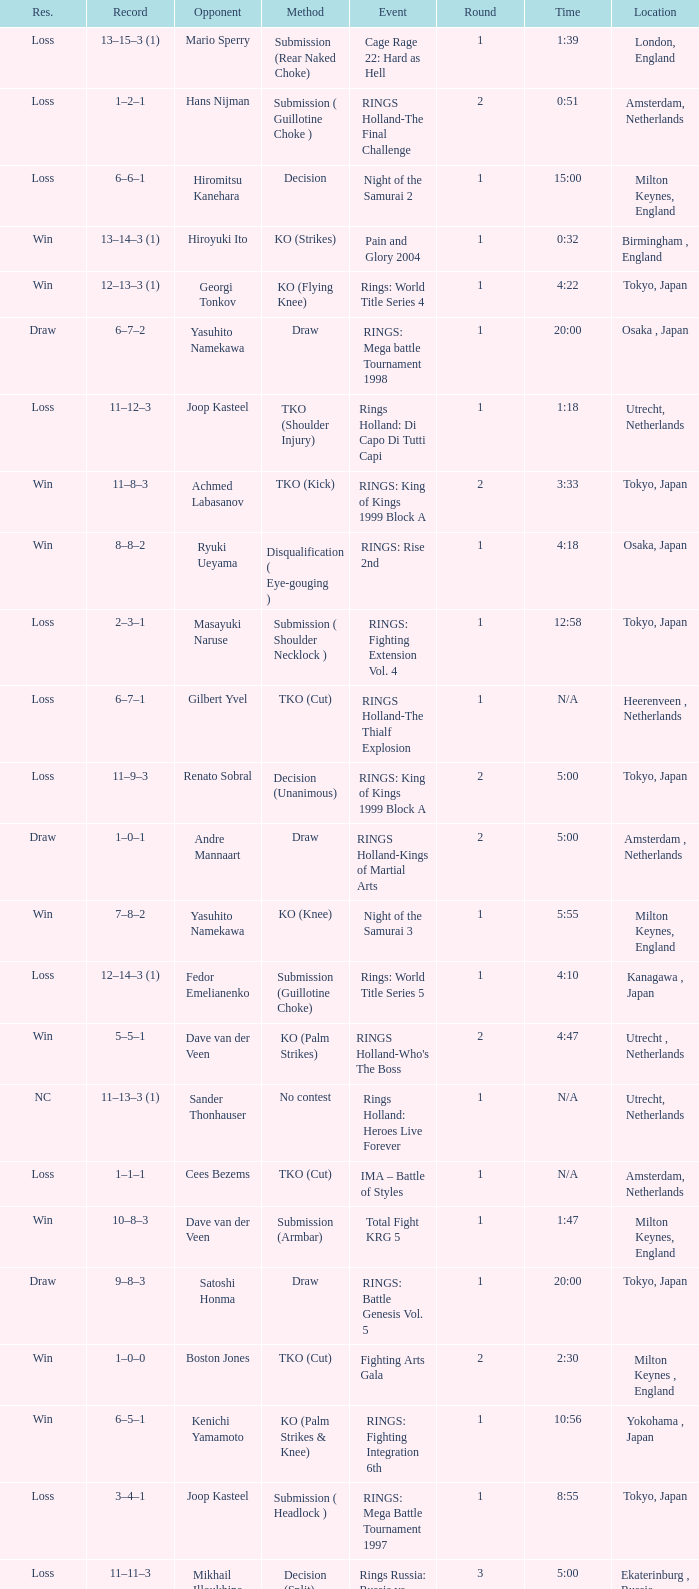What is the time for an opponent of Satoshi Honma? 20:00. 